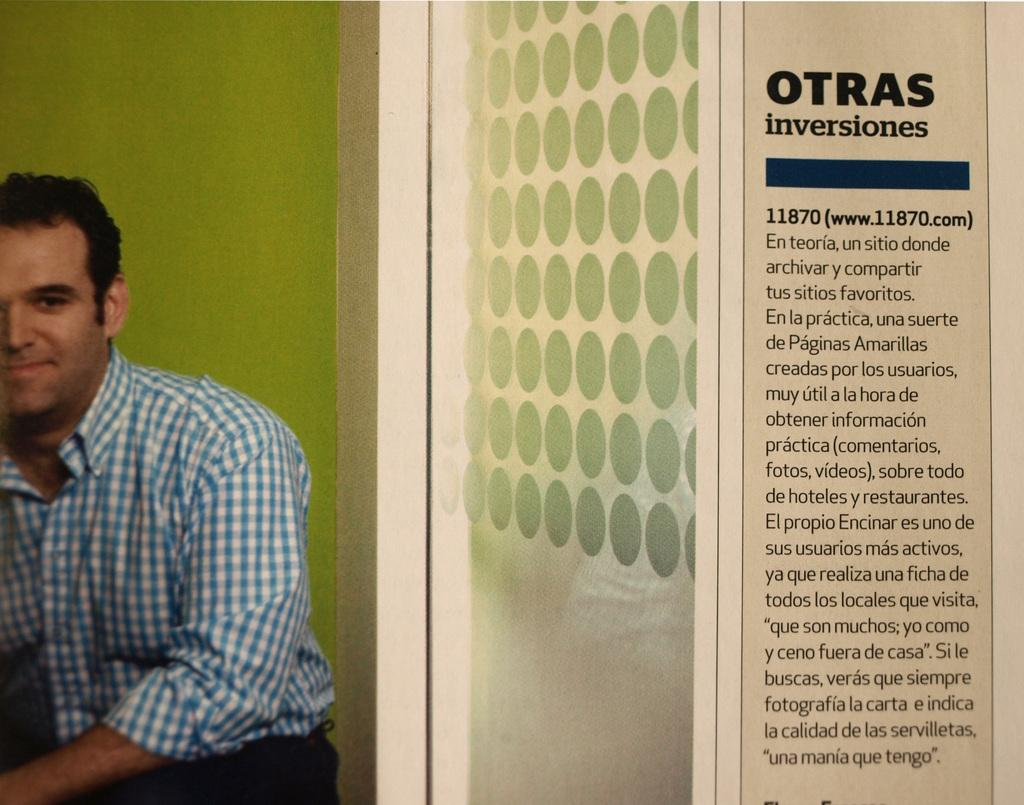What can be found on the right side of the image? There is text on the right side of the image. What is located on the left side of the image? There is a wall on the left side of the image. Is there a person visible in the image? Yes, there is a person on the left side of the image. What type of help can be provided by the secretary in the image? There is no secretary present in the image, so it is not possible to answer that question. 